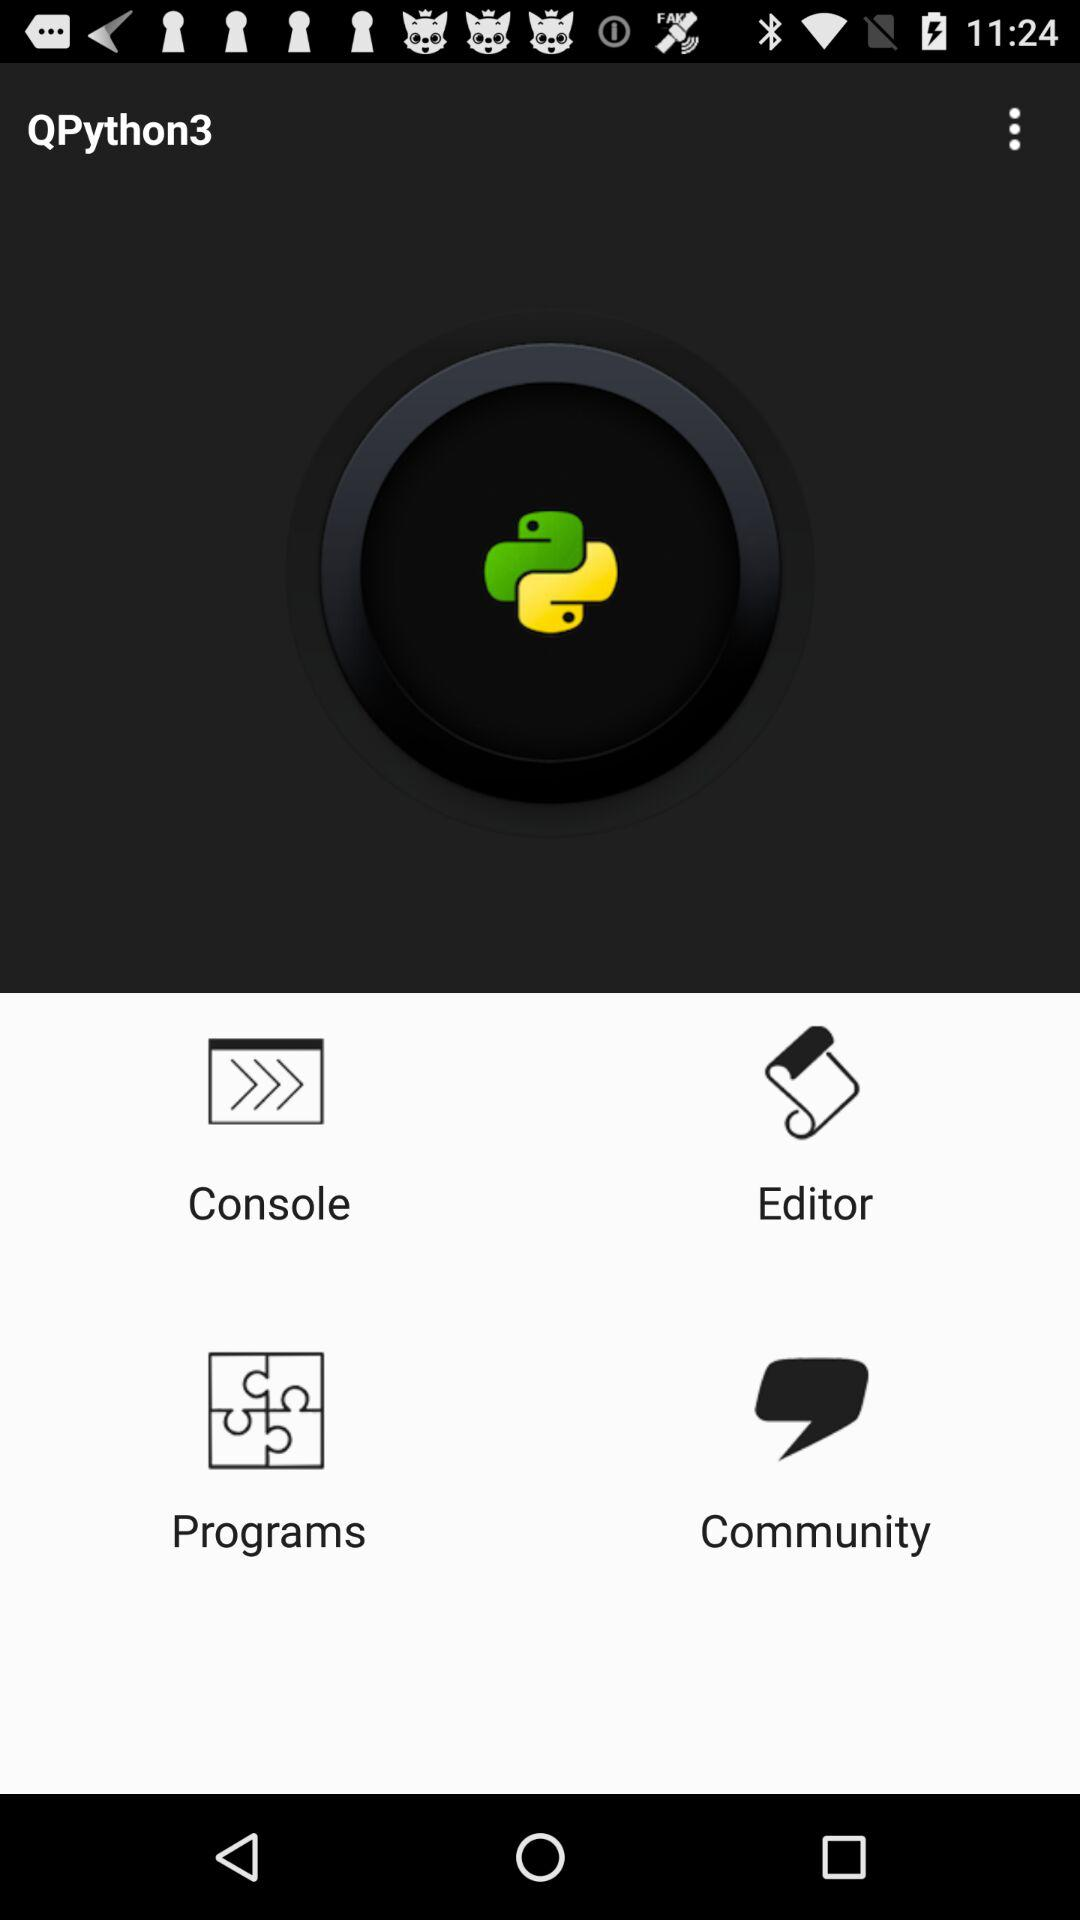What are the available options? The available options are "Console", "Editor", "Programs" and "Community". 